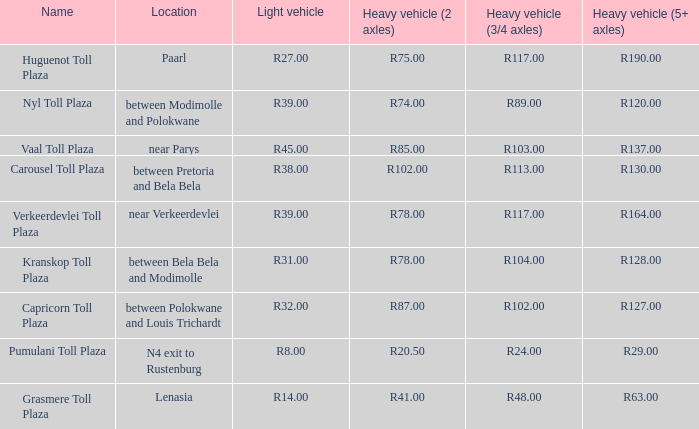Parse the table in full. {'header': ['Name', 'Location', 'Light vehicle', 'Heavy vehicle (2 axles)', 'Heavy vehicle (3/4 axles)', 'Heavy vehicle (5+ axles)'], 'rows': [['Huguenot Toll Plaza', 'Paarl', 'R27.00', 'R75.00', 'R117.00', 'R190.00'], ['Nyl Toll Plaza', 'between Modimolle and Polokwane', 'R39.00', 'R74.00', 'R89.00', 'R120.00'], ['Vaal Toll Plaza', 'near Parys', 'R45.00', 'R85.00', 'R103.00', 'R137.00'], ['Carousel Toll Plaza', 'between Pretoria and Bela Bela', 'R38.00', 'R102.00', 'R113.00', 'R130.00'], ['Verkeerdevlei Toll Plaza', 'near Verkeerdevlei', 'R39.00', 'R78.00', 'R117.00', 'R164.00'], ['Kranskop Toll Plaza', 'between Bela Bela and Modimolle', 'R31.00', 'R78.00', 'R104.00', 'R128.00'], ['Capricorn Toll Plaza', 'between Polokwane and Louis Trichardt', 'R32.00', 'R87.00', 'R102.00', 'R127.00'], ['Pumulani Toll Plaza', 'N4 exit to Rustenburg', 'R8.00', 'R20.50', 'R24.00', 'R29.00'], ['Grasmere Toll Plaza', 'Lenasia', 'R14.00', 'R41.00', 'R48.00', 'R63.00']]} What is the name of the plaza where the toll for heavy vehicles with 2 axles is r87.00? Capricorn Toll Plaza. 